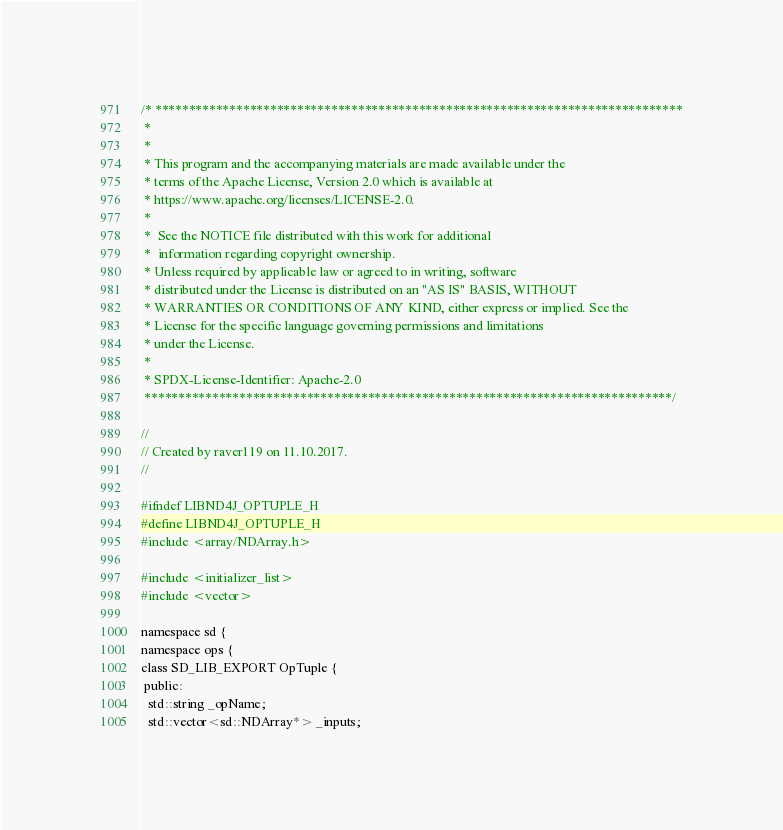<code> <loc_0><loc_0><loc_500><loc_500><_C_>/* ******************************************************************************
 *
 *
 * This program and the accompanying materials are made available under the
 * terms of the Apache License, Version 2.0 which is available at
 * https://www.apache.org/licenses/LICENSE-2.0.
 *
 *  See the NOTICE file distributed with this work for additional
 *  information regarding copyright ownership.
 * Unless required by applicable law or agreed to in writing, software
 * distributed under the License is distributed on an "AS IS" BASIS, WITHOUT
 * WARRANTIES OR CONDITIONS OF ANY KIND, either express or implied. See the
 * License for the specific language governing permissions and limitations
 * under the License.
 *
 * SPDX-License-Identifier: Apache-2.0
 ******************************************************************************/

//
// Created by raver119 on 11.10.2017.
//

#ifndef LIBND4J_OPTUPLE_H
#define LIBND4J_OPTUPLE_H
#include <array/NDArray.h>

#include <initializer_list>
#include <vector>

namespace sd {
namespace ops {
class SD_LIB_EXPORT OpTuple {
 public:
  std::string _opName;
  std::vector<sd::NDArray*> _inputs;</code> 